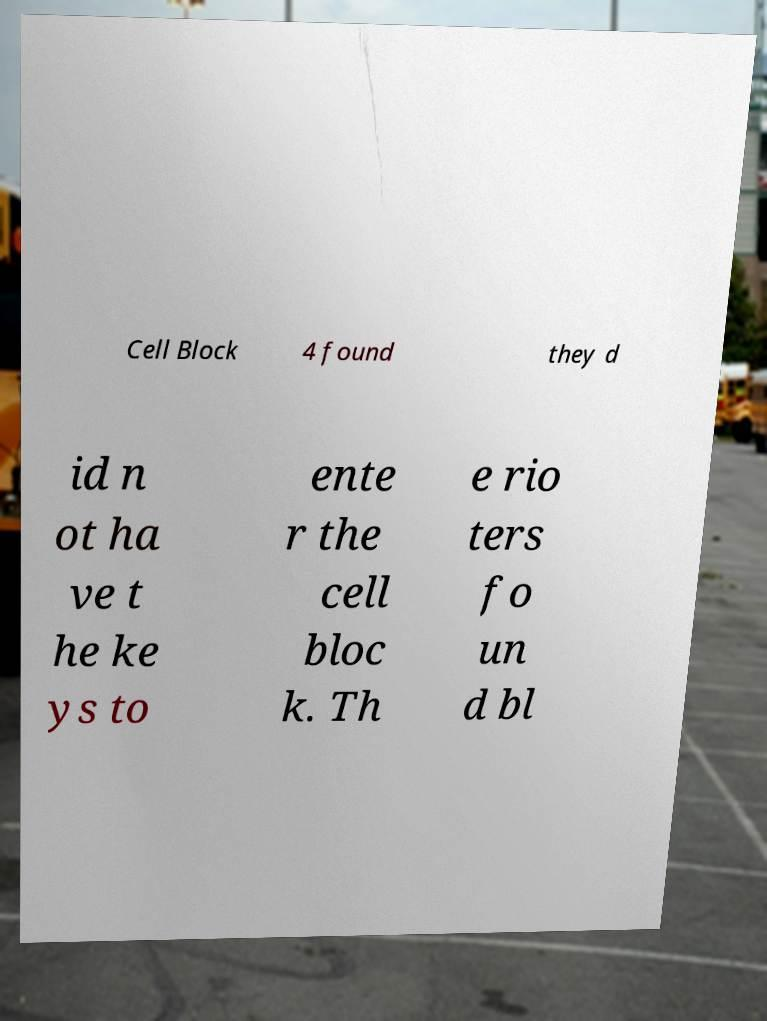I need the written content from this picture converted into text. Can you do that? Cell Block 4 found they d id n ot ha ve t he ke ys to ente r the cell bloc k. Th e rio ters fo un d bl 